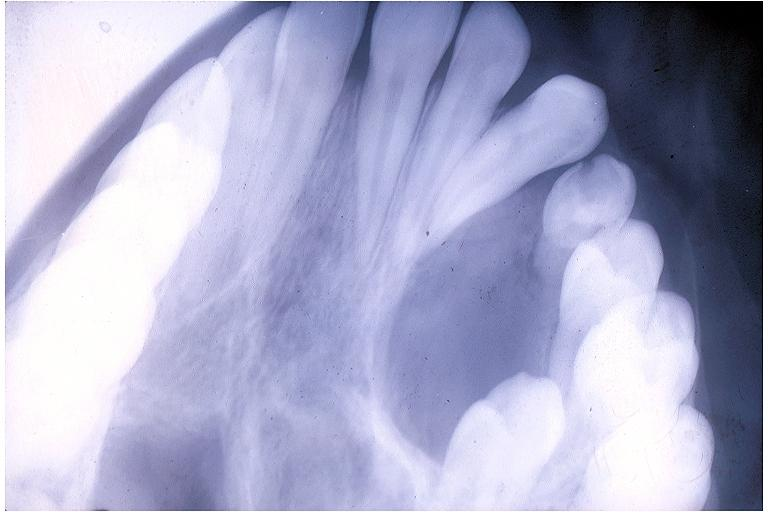s oral present?
Answer the question using a single word or phrase. Yes 